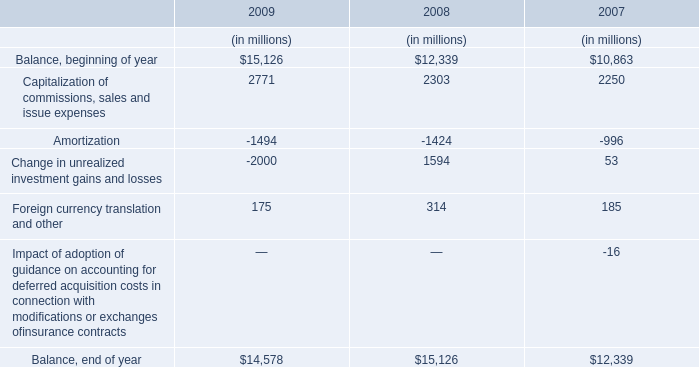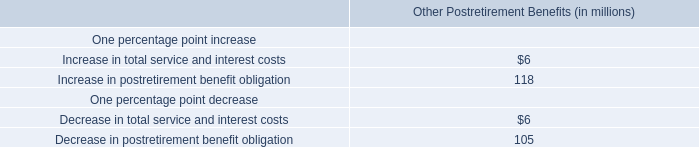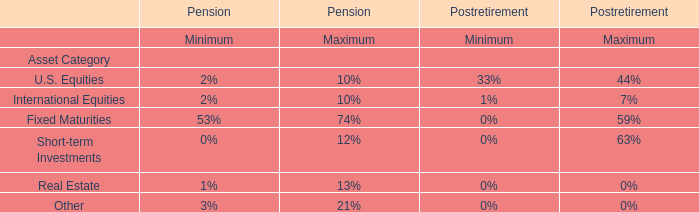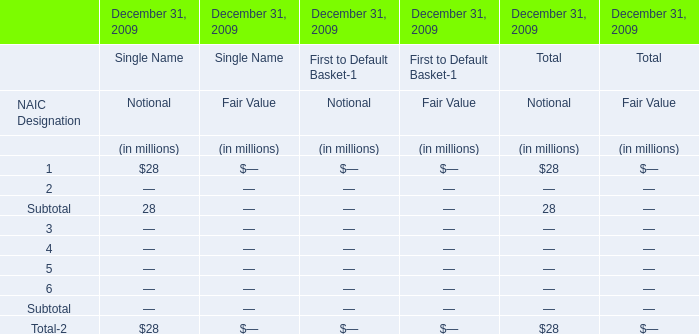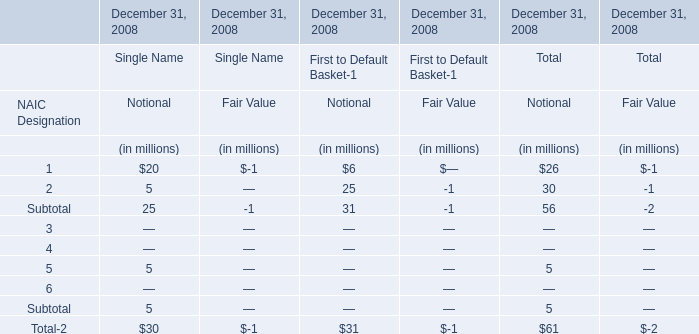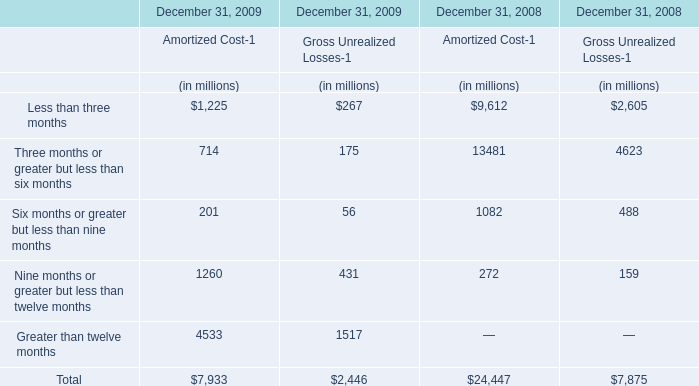What was the total amount of Subtotal in 2008? (in million) 
Computations: (((((25 - 1) + 31) - 1) + 56) - 2)
Answer: 108.0. 